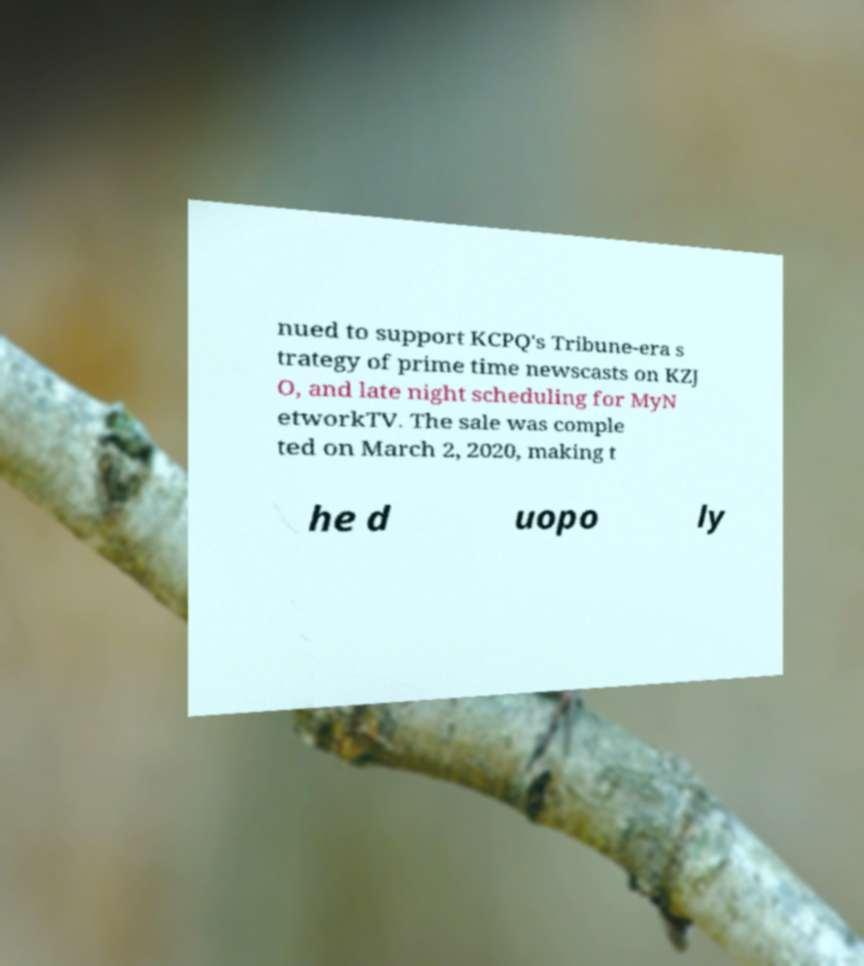Please read and relay the text visible in this image. What does it say? nued to support KCPQ's Tribune-era s trategy of prime time newscasts on KZJ O, and late night scheduling for MyN etworkTV. The sale was comple ted on March 2, 2020, making t he d uopo ly 